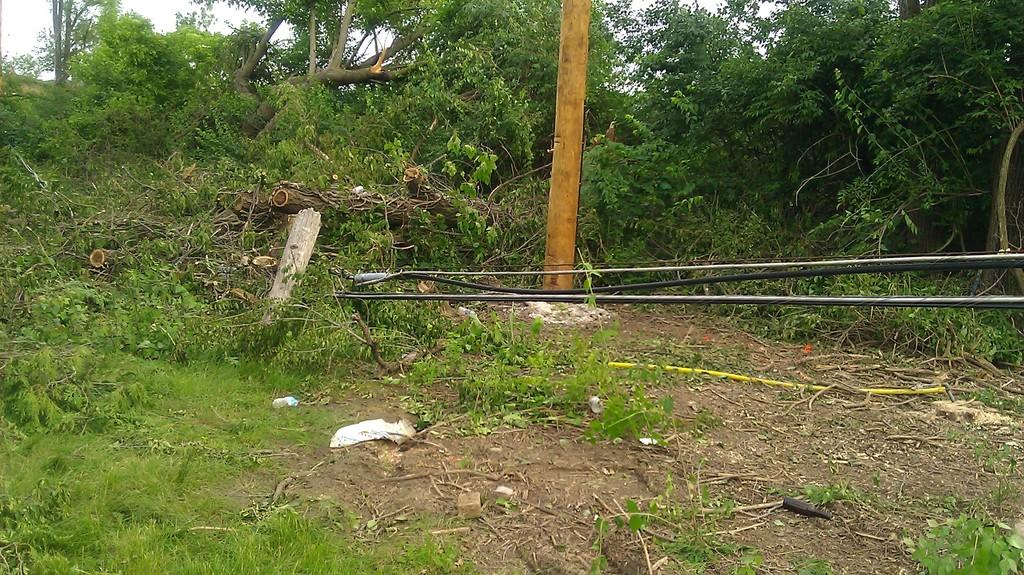What type of natural elements can be seen in the image? There are trees in the image. What is the color of the object in the image? The object in the image is in gold color. What type of materials are the pipes made of in the image? The pipes in the image are made of black and stainless steel. How many passengers are waiting at the harbor in the image? There is no harbor or passengers present in the image. What type of burn is visible on the trees in the image? There is no burn visible on the trees in the image; they appear to be healthy. 